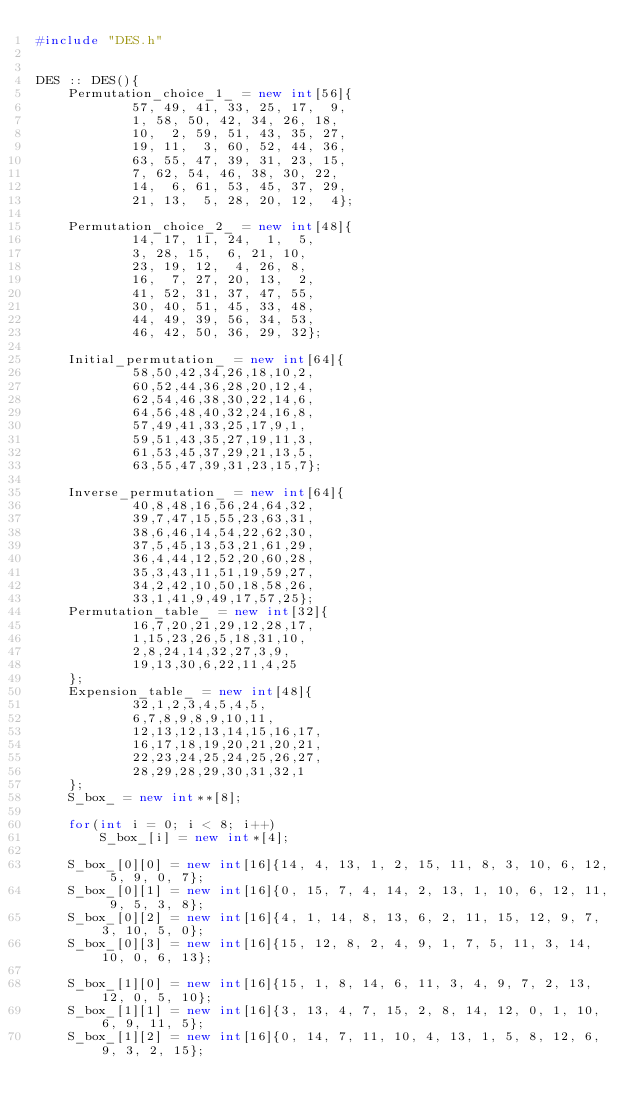Convert code to text. <code><loc_0><loc_0><loc_500><loc_500><_C++_>#include "DES.h"


DES :: DES(){
    Permutation_choice_1_ = new int[56]{
            57, 49, 41, 33, 25, 17,  9,
            1, 58, 50, 42, 34, 26, 18,
            10,  2, 59, 51, 43, 35, 27,
            19, 11,  3, 60, 52, 44, 36,
            63, 55, 47, 39, 31, 23, 15,
            7, 62, 54, 46, 38, 30, 22,
            14,  6, 61, 53, 45, 37, 29,
            21, 13,  5, 28, 20, 12,  4};

    Permutation_choice_2_ = new int[48]{
            14, 17, 11, 24,  1,  5,
            3, 28, 15,  6, 21, 10,
            23, 19, 12,  4, 26, 8,
            16,  7, 27, 20, 13,  2,
            41, 52, 31, 37, 47, 55,
            30, 40, 51, 45, 33, 48,
            44, 49, 39, 56, 34, 53,
            46, 42, 50, 36, 29, 32};

    Initial_permutation_ = new int[64]{
            58,50,42,34,26,18,10,2,
            60,52,44,36,28,20,12,4,
            62,54,46,38,30,22,14,6,
            64,56,48,40,32,24,16,8,
            57,49,41,33,25,17,9,1,
            59,51,43,35,27,19,11,3,
            61,53,45,37,29,21,13,5,
            63,55,47,39,31,23,15,7};

    Inverse_permutation_ = new int[64]{
            40,8,48,16,56,24,64,32,
            39,7,47,15,55,23,63,31,
            38,6,46,14,54,22,62,30,
            37,5,45,13,53,21,61,29,
            36,4,44,12,52,20,60,28,
            35,3,43,11,51,19,59,27,
            34,2,42,10,50,18,58,26,
            33,1,41,9,49,17,57,25};
    Permutation_table_ = new int[32]{
            16,7,20,21,29,12,28,17,
            1,15,23,26,5,18,31,10,
            2,8,24,14,32,27,3,9,
            19,13,30,6,22,11,4,25
    };
    Expension_table_ = new int[48]{
            32,1,2,3,4,5,4,5,
            6,7,8,9,8,9,10,11,
            12,13,12,13,14,15,16,17,
            16,17,18,19,20,21,20,21,
            22,23,24,25,24,25,26,27,
            28,29,28,29,30,31,32,1
    };
    S_box_ = new int**[8];

    for(int i = 0; i < 8; i++)
        S_box_[i] = new int*[4];

    S_box_[0][0] = new int[16]{14, 4, 13, 1, 2, 15, 11, 8, 3, 10, 6, 12, 5, 9, 0, 7};
    S_box_[0][1] = new int[16]{0, 15, 7, 4, 14, 2, 13, 1, 10, 6, 12, 11, 9, 5, 3, 8};
    S_box_[0][2] = new int[16]{4, 1, 14, 8, 13, 6, 2, 11, 15, 12, 9, 7, 3, 10, 5, 0};
    S_box_[0][3] = new int[16]{15, 12, 8, 2, 4, 9, 1, 7, 5, 11, 3, 14, 10, 0, 6, 13};

    S_box_[1][0] = new int[16]{15, 1, 8, 14, 6, 11, 3, 4, 9, 7, 2, 13, 12, 0, 5, 10};
    S_box_[1][1] = new int[16]{3, 13, 4, 7, 15, 2, 8, 14, 12, 0, 1, 10, 6, 9, 11, 5};
    S_box_[1][2] = new int[16]{0, 14, 7, 11, 10, 4, 13, 1, 5, 8, 12, 6, 9, 3, 2, 15};</code> 